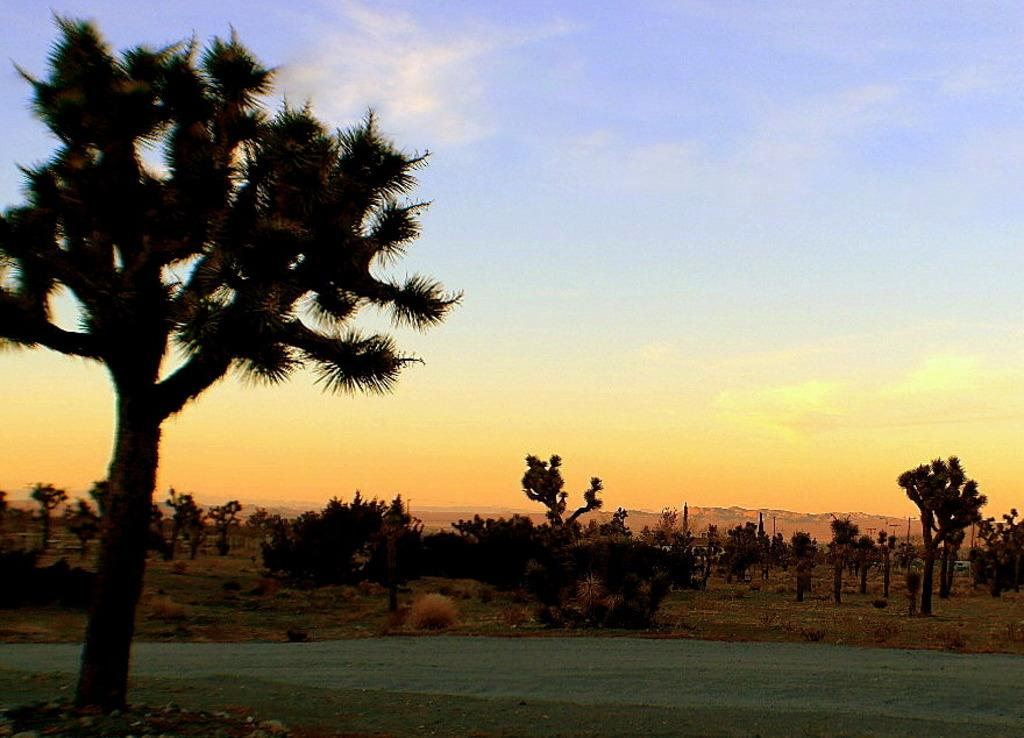What type of vegetation can be seen in the image? There are trees in the image. What part of the natural environment is visible in the image? The ground is visible in the image. What can be seen in the background of the image? The sky is visible in the background of the image. What type of coal can be seen on the street in the image? There is no coal or street present in the image; it features trees, ground, and sky. What type of grass is growing on the trees in the image? There is no grass growing on the trees in the image; the trees are separate from the ground. 